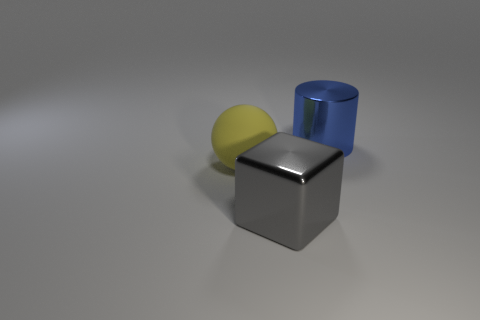Can you tell me what materials the objects might be made of based on their appearance? Based on their appearance, the yellow ball might be made of a matte plastic due to its dull sheen. The gray cube appears to be metal, as indicated by its reflective surface, and the blue cylinder looks like it could also be made of a metallic material, given its reflective and smooth surface. 